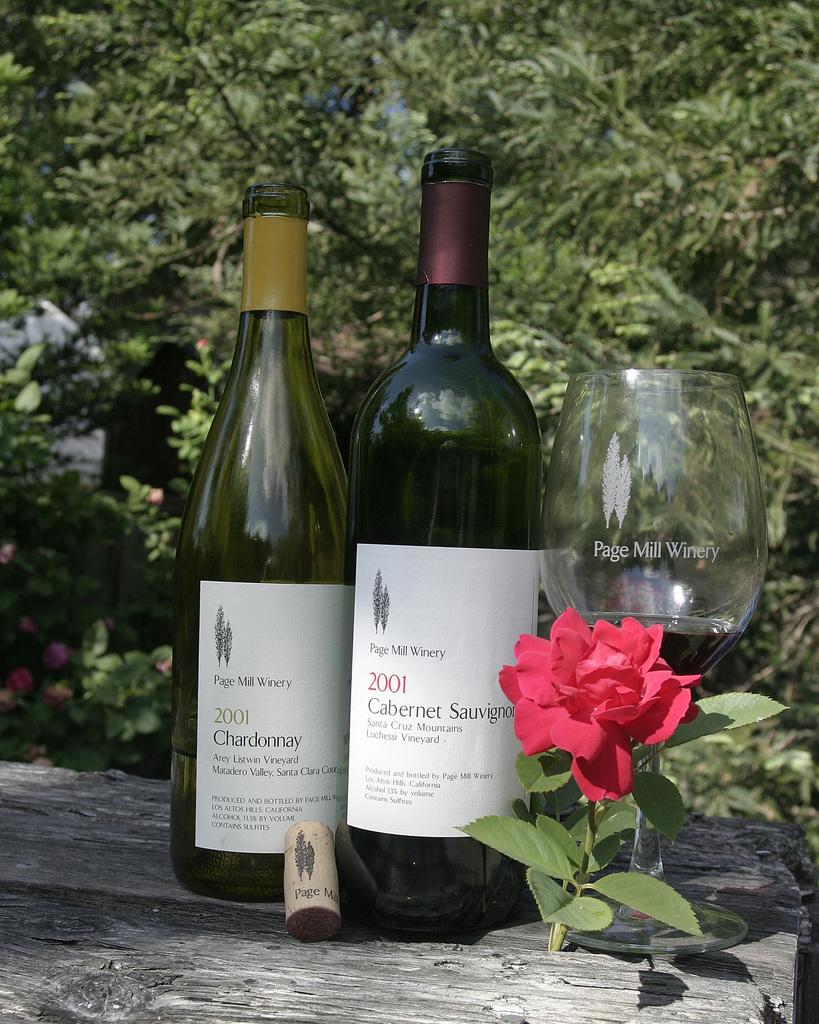When were both these wines bottled?
Provide a short and direct response. 2001. What kind of wine is on the right?
Keep it short and to the point. Cabernet sauvignon. 